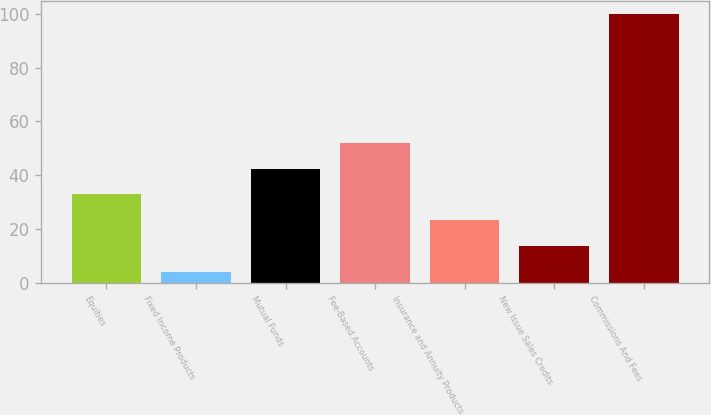Convert chart. <chart><loc_0><loc_0><loc_500><loc_500><bar_chart><fcel>Equities<fcel>Fixed Income Products<fcel>Mutual Funds<fcel>Fee-Based Accounts<fcel>Insurance and Annuity Products<fcel>New Issue Sales Credits<fcel>Commissions And Fees<nl><fcel>32.8<fcel>4<fcel>42.4<fcel>52<fcel>23.2<fcel>13.6<fcel>100<nl></chart> 